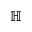<formula> <loc_0><loc_0><loc_500><loc_500>\mathbb { H }</formula> 